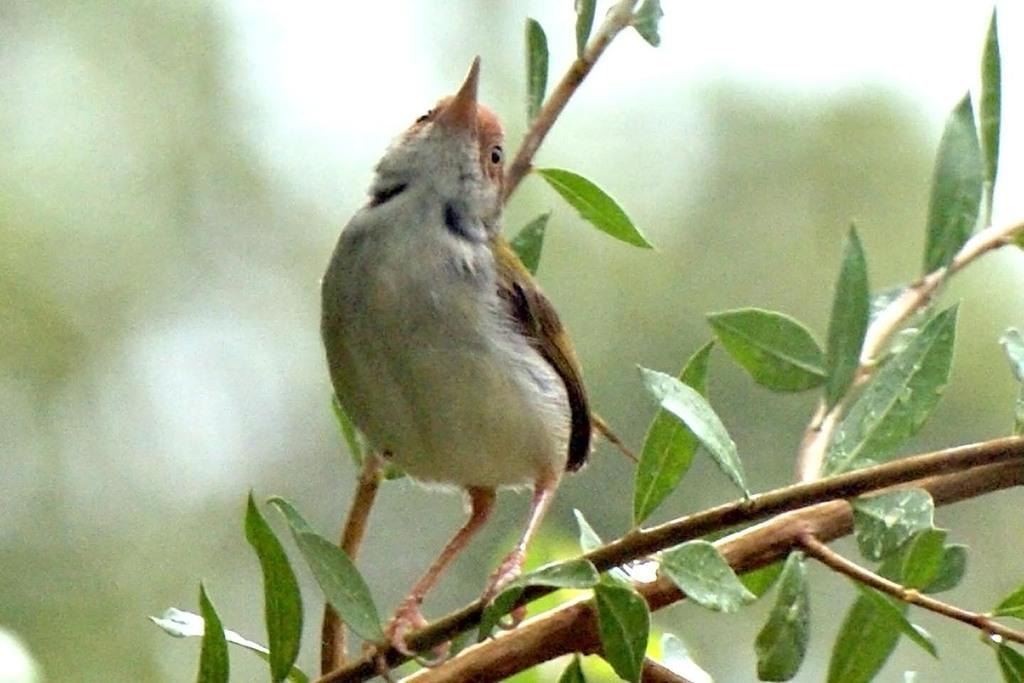What type of animal can be seen in the image? There is a bird in the image. Where is the bird positioned in the image? The bird is standing on a stem. What else can be seen on the stem? There are leaves on the stem. Can you describe the background of the image? The background of the image is blurry. How does the bird participate in a kissing scene in the image? There is no kissing scene present in the image, and the bird is not involved in any such activity. 